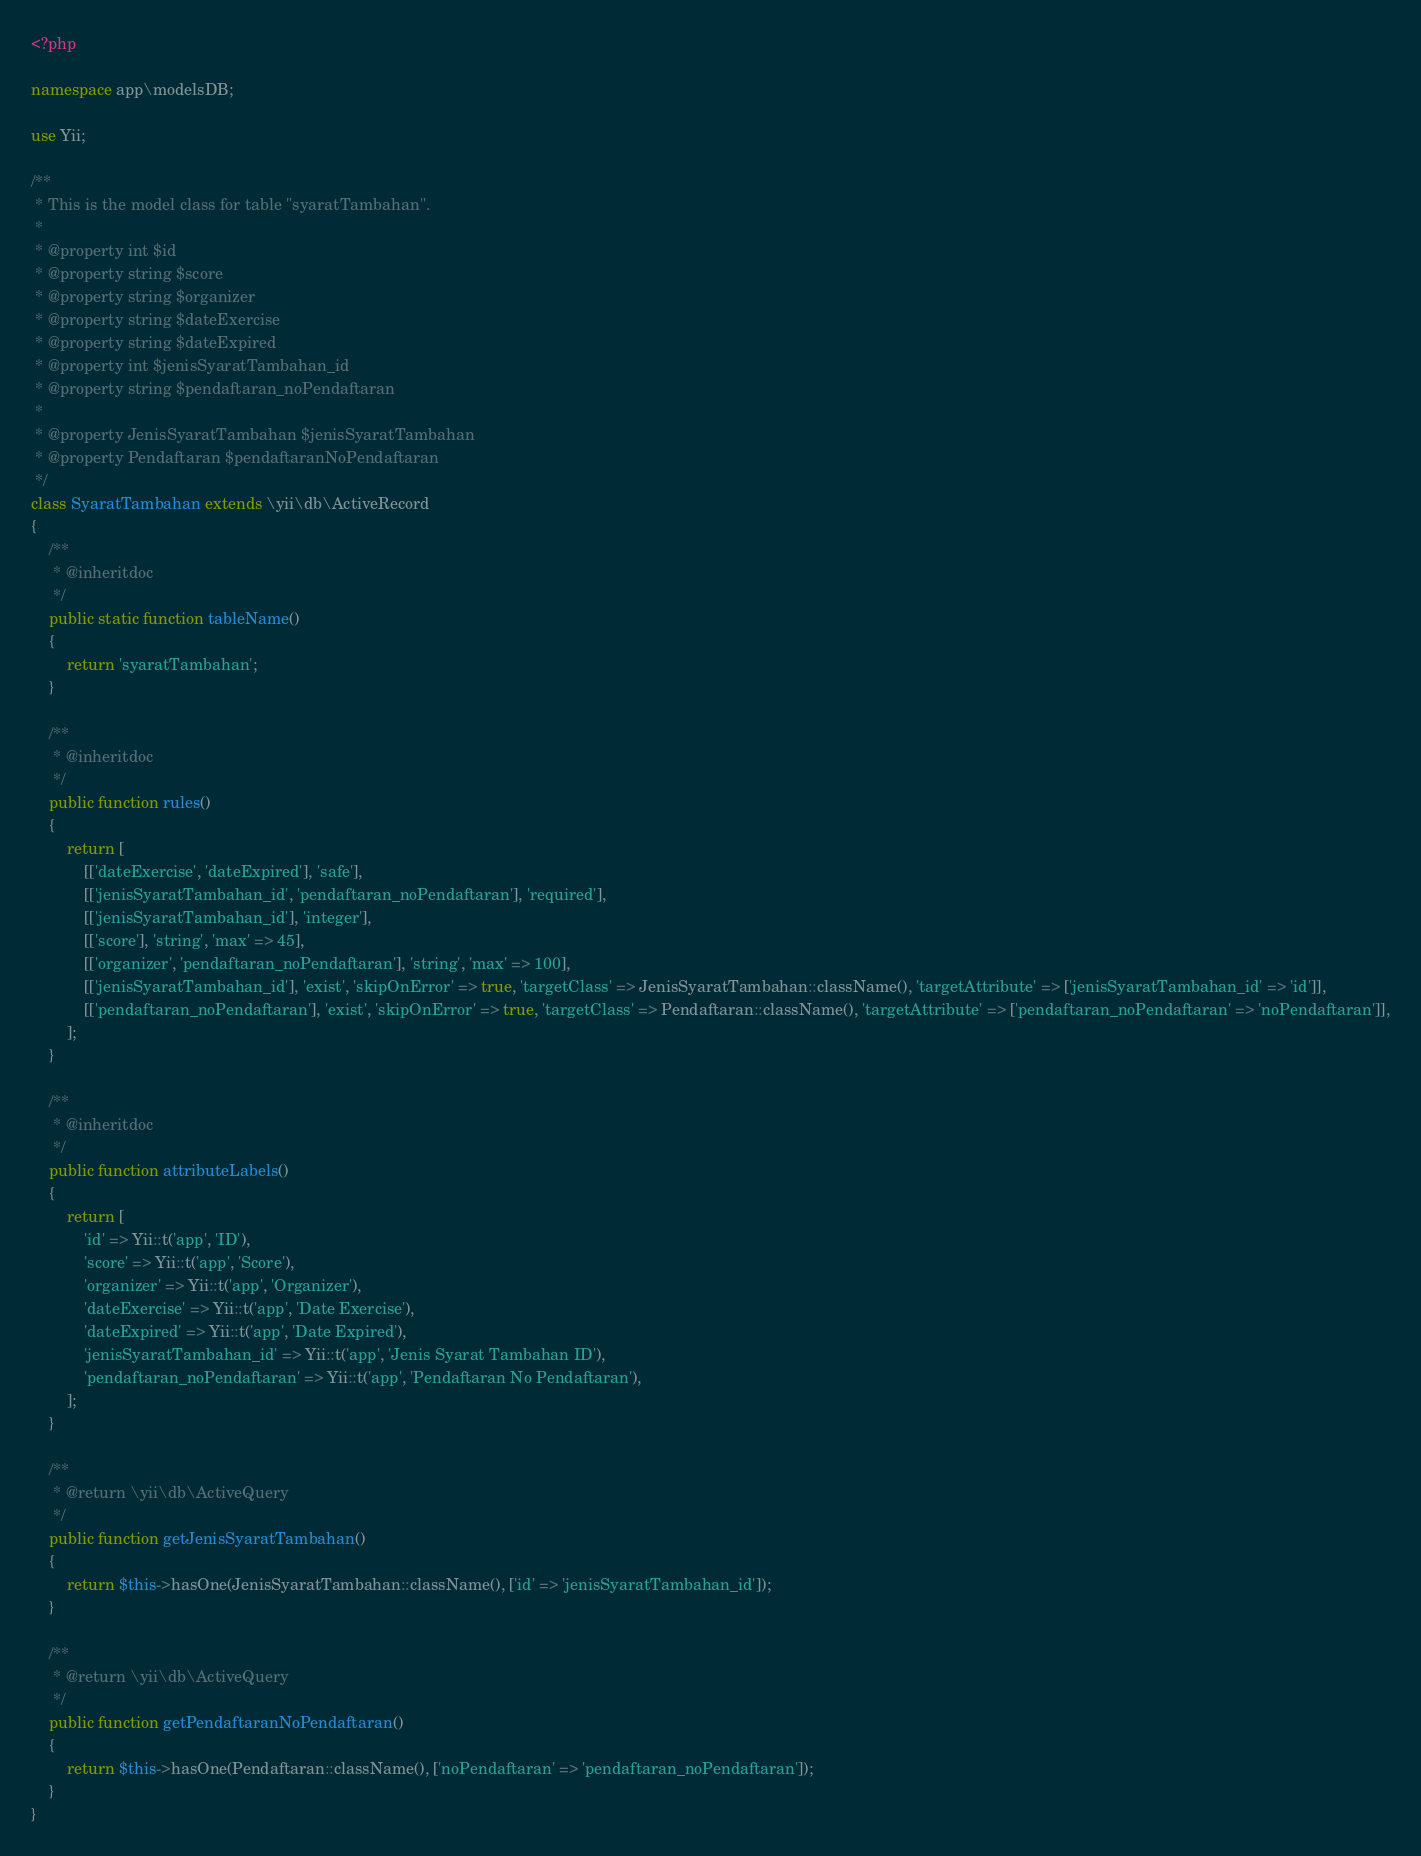Convert code to text. <code><loc_0><loc_0><loc_500><loc_500><_PHP_><?php

namespace app\modelsDB;

use Yii;

/**
 * This is the model class for table "syaratTambahan".
 *
 * @property int $id
 * @property string $score
 * @property string $organizer
 * @property string $dateExercise
 * @property string $dateExpired
 * @property int $jenisSyaratTambahan_id
 * @property string $pendaftaran_noPendaftaran
 *
 * @property JenisSyaratTambahan $jenisSyaratTambahan
 * @property Pendaftaran $pendaftaranNoPendaftaran
 */
class SyaratTambahan extends \yii\db\ActiveRecord
{
    /**
     * @inheritdoc
     */
    public static function tableName()
    {
        return 'syaratTambahan';
    }

    /**
     * @inheritdoc
     */
    public function rules()
    {
        return [
            [['dateExercise', 'dateExpired'], 'safe'],
            [['jenisSyaratTambahan_id', 'pendaftaran_noPendaftaran'], 'required'],
            [['jenisSyaratTambahan_id'], 'integer'],
            [['score'], 'string', 'max' => 45],
            [['organizer', 'pendaftaran_noPendaftaran'], 'string', 'max' => 100],
            [['jenisSyaratTambahan_id'], 'exist', 'skipOnError' => true, 'targetClass' => JenisSyaratTambahan::className(), 'targetAttribute' => ['jenisSyaratTambahan_id' => 'id']],
            [['pendaftaran_noPendaftaran'], 'exist', 'skipOnError' => true, 'targetClass' => Pendaftaran::className(), 'targetAttribute' => ['pendaftaran_noPendaftaran' => 'noPendaftaran']],
        ];
    }

    /**
     * @inheritdoc
     */
    public function attributeLabels()
    {
        return [
            'id' => Yii::t('app', 'ID'),
            'score' => Yii::t('app', 'Score'),
            'organizer' => Yii::t('app', 'Organizer'),
            'dateExercise' => Yii::t('app', 'Date Exercise'),
            'dateExpired' => Yii::t('app', 'Date Expired'),
            'jenisSyaratTambahan_id' => Yii::t('app', 'Jenis Syarat Tambahan ID'),
            'pendaftaran_noPendaftaran' => Yii::t('app', 'Pendaftaran No Pendaftaran'),
        ];
    }

    /**
     * @return \yii\db\ActiveQuery
     */
    public function getJenisSyaratTambahan()
    {
        return $this->hasOne(JenisSyaratTambahan::className(), ['id' => 'jenisSyaratTambahan_id']);
    }

    /**
     * @return \yii\db\ActiveQuery
     */
    public function getPendaftaranNoPendaftaran()
    {
        return $this->hasOne(Pendaftaran::className(), ['noPendaftaran' => 'pendaftaran_noPendaftaran']);
    }
}
</code> 